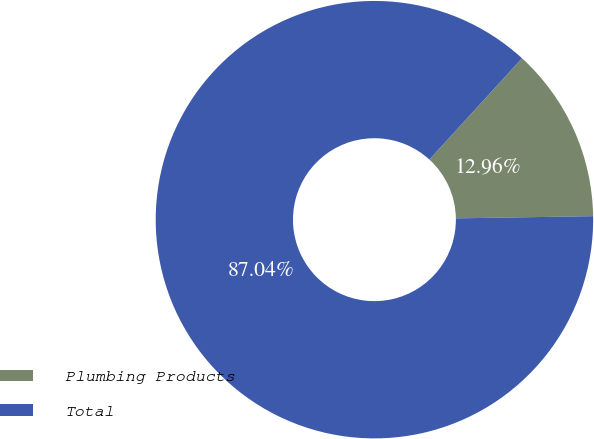Convert chart to OTSL. <chart><loc_0><loc_0><loc_500><loc_500><pie_chart><fcel>Plumbing Products<fcel>Total<nl><fcel>12.96%<fcel>87.04%<nl></chart> 